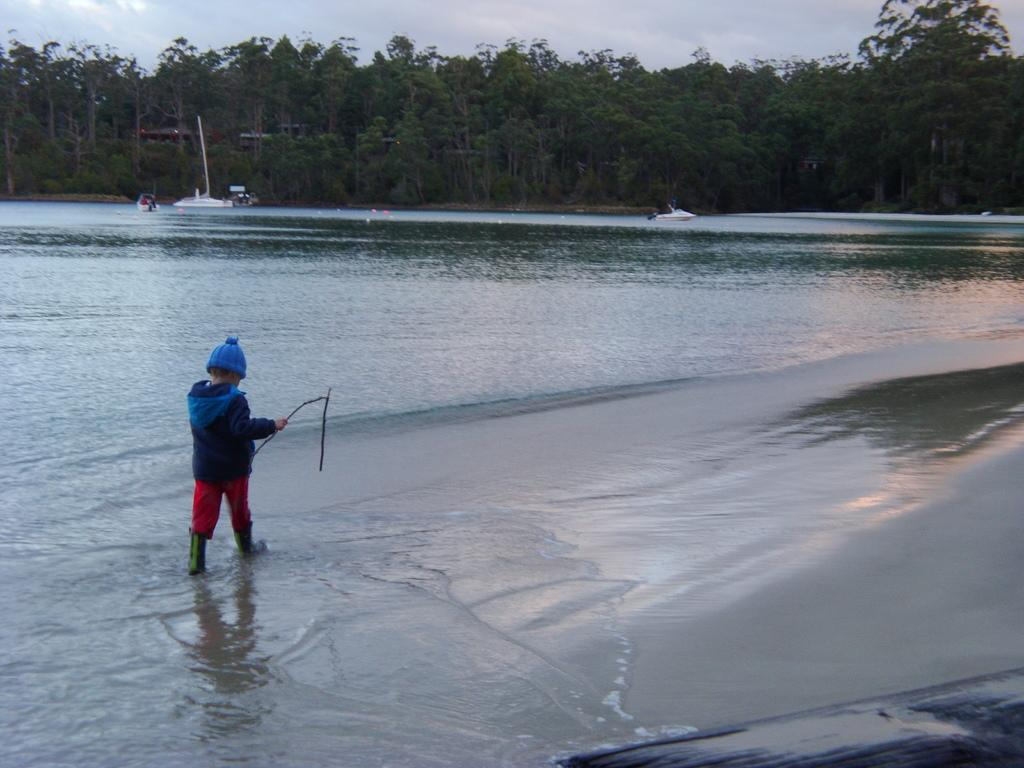Who is the main subject in the image? There is a boy in the image. What is the boy doing in the image? The boy is walking in the water. What type of natural environment is visible in the image? There are trees in the image. What part of the natural environment is visible in the image? The sky is visible in the image. What type of fowl can be seen swimming alongside the boy in the image? There is no fowl present in the image; the boy is walking alone in the water. 